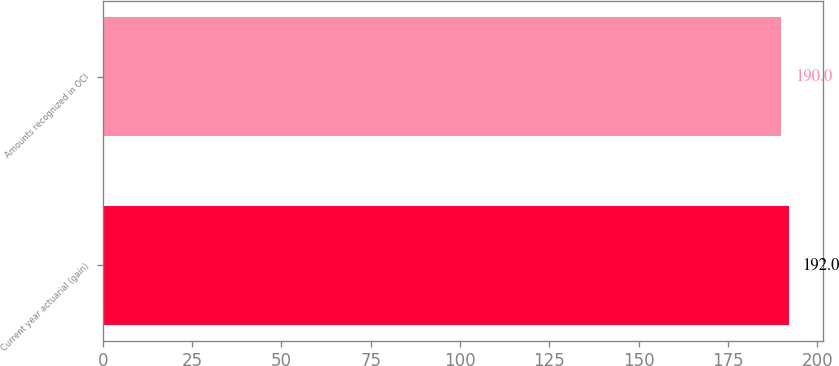Convert chart. <chart><loc_0><loc_0><loc_500><loc_500><bar_chart><fcel>Current year actuarial (gain)<fcel>Amounts recognized in OCI<nl><fcel>192<fcel>190<nl></chart> 